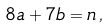<formula> <loc_0><loc_0><loc_500><loc_500>8 a + 7 b = n \, ,</formula> 